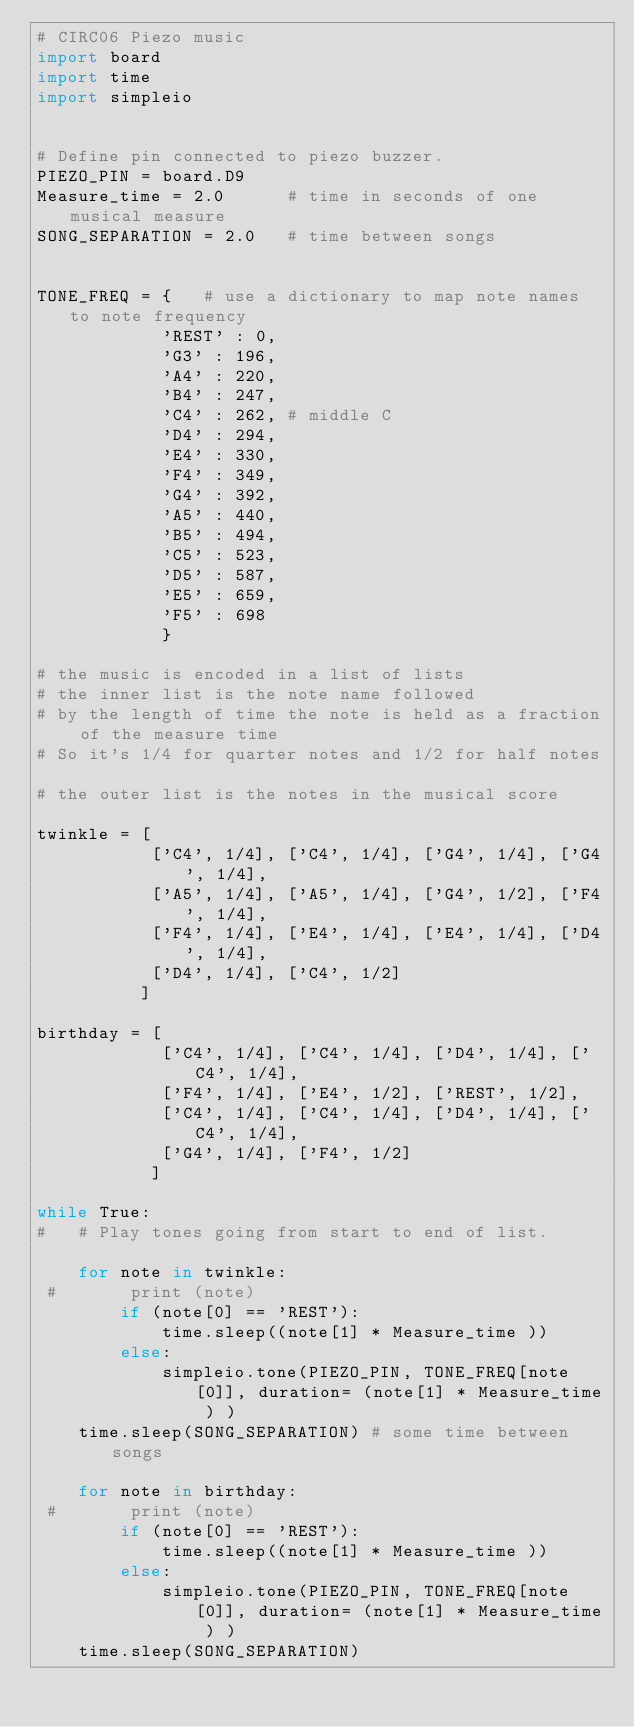Convert code to text. <code><loc_0><loc_0><loc_500><loc_500><_Python_># CIRC06 Piezo music
import board
import time
import simpleio


# Define pin connected to piezo buzzer.
PIEZO_PIN = board.D9
Measure_time = 2.0      # time in seconds of one musical measure
SONG_SEPARATION = 2.0   # time between songs


TONE_FREQ = {   # use a dictionary to map note names to note frequency
            'REST' : 0,
            'G3' : 196,
            'A4' : 220,
            'B4' : 247,
            'C4' : 262, # middle C
            'D4' : 294,
            'E4' : 330,
            'F4' : 349,
            'G4' : 392,
            'A5' : 440,
            'B5' : 494,
            'C5' : 523,
            'D5' : 587,
            'E5' : 659,
            'F5' : 698
            }

# the music is encoded in a list of lists
# the inner list is the note name followed
# by the length of time the note is held as a fraction of the measure time
# So it's 1/4 for quarter notes and 1/2 for half notes

# the outer list is the notes in the musical score

twinkle = [
           ['C4', 1/4], ['C4', 1/4], ['G4', 1/4], ['G4', 1/4],
           ['A5', 1/4], ['A5', 1/4], ['G4', 1/2], ['F4', 1/4],
           ['F4', 1/4], ['E4', 1/4], ['E4', 1/4], ['D4', 1/4],
           ['D4', 1/4], ['C4', 1/2]
          ]

birthday = [
            ['C4', 1/4], ['C4', 1/4], ['D4', 1/4], ['C4', 1/4],
            ['F4', 1/4], ['E4', 1/2], ['REST', 1/2],
            ['C4', 1/4], ['C4', 1/4], ['D4', 1/4], ['C4', 1/4],
            ['G4', 1/4], ['F4', 1/2]
           ]

while True:
#   # Play tones going from start to end of list.

    for note in twinkle:
 #       print (note)
        if (note[0] == 'REST'):
            time.sleep((note[1] * Measure_time ))
        else:
            simpleio.tone(PIEZO_PIN, TONE_FREQ[note[0]], duration= (note[1] * Measure_time ) )
    time.sleep(SONG_SEPARATION) # some time between songs

    for note in birthday:
 #       print (note)
        if (note[0] == 'REST'):
            time.sleep((note[1] * Measure_time ))
        else:
            simpleio.tone(PIEZO_PIN, TONE_FREQ[note[0]], duration= (note[1] * Measure_time ) )
    time.sleep(SONG_SEPARATION)</code> 